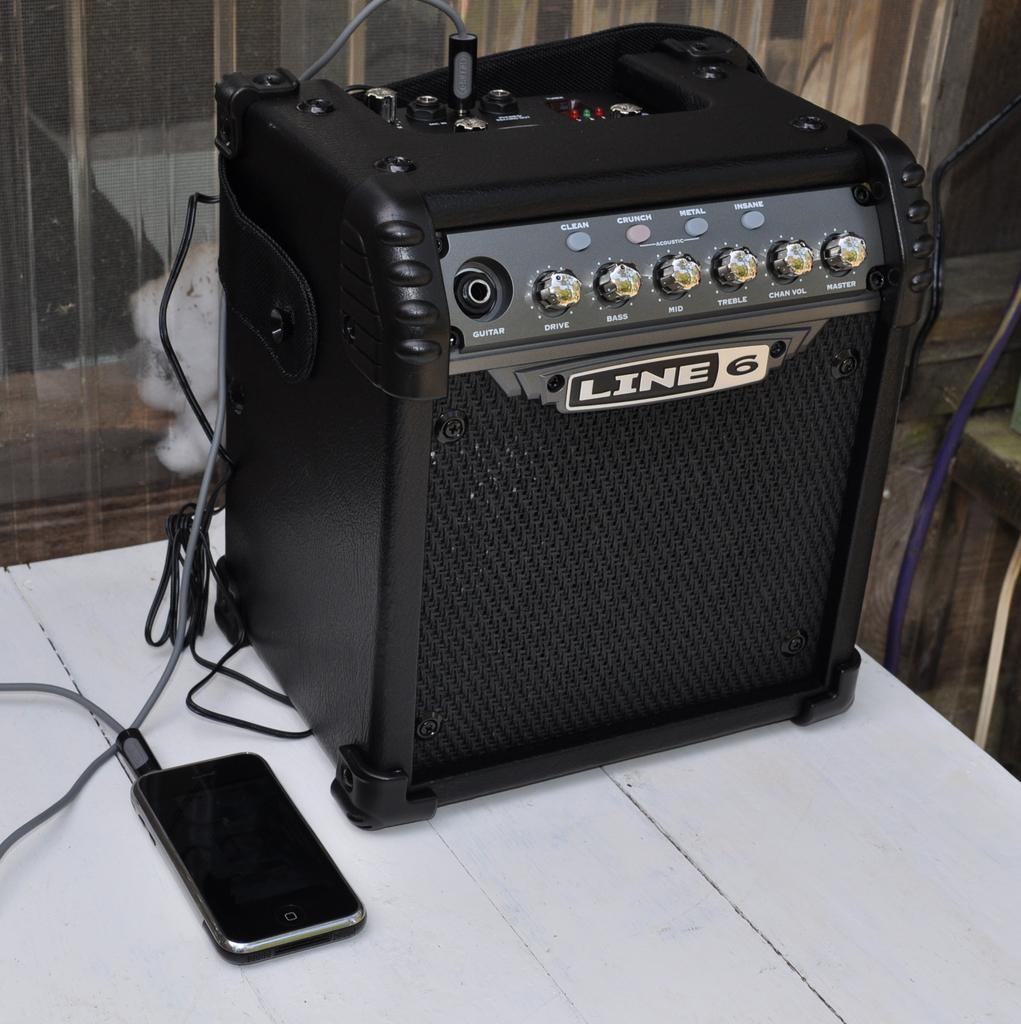<image>
Share a concise interpretation of the image provided. A cellphone is connected to a Line 6 amplifier. 